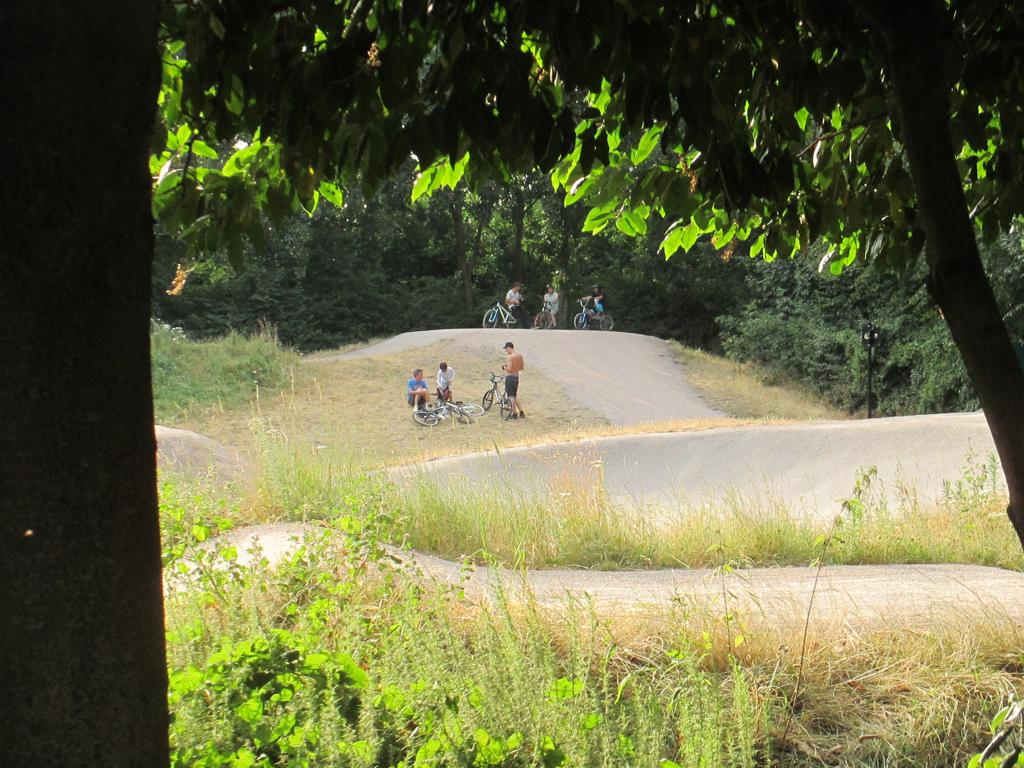What type of vegetation is present in the image? There is grass and trees in the image. What objects can be seen in the image that are used for transportation? There are bicycles in the image. Who is present in the image? There is a group of people in the image. When was the image likely taken? The image appears to be taken during the day. What is the condition of the line in the image? There is no line present in the image. What day of the week is depicted in the image? The day of the week is not mentioned or visible in the image. 